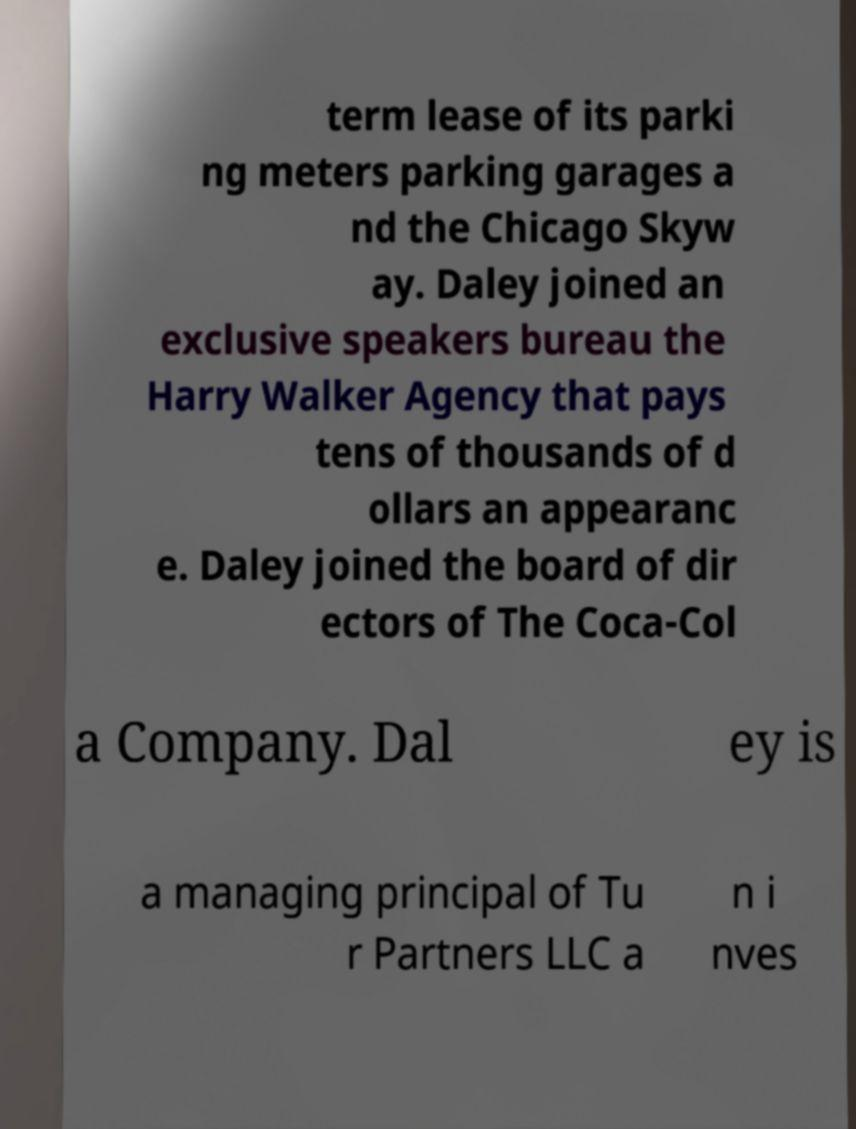Can you accurately transcribe the text from the provided image for me? term lease of its parki ng meters parking garages a nd the Chicago Skyw ay. Daley joined an exclusive speakers bureau the Harry Walker Agency that pays tens of thousands of d ollars an appearanc e. Daley joined the board of dir ectors of The Coca-Col a Company. Dal ey is a managing principal of Tu r Partners LLC a n i nves 